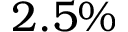Convert formula to latex. <formula><loc_0><loc_0><loc_500><loc_500>2 . 5 \%</formula> 